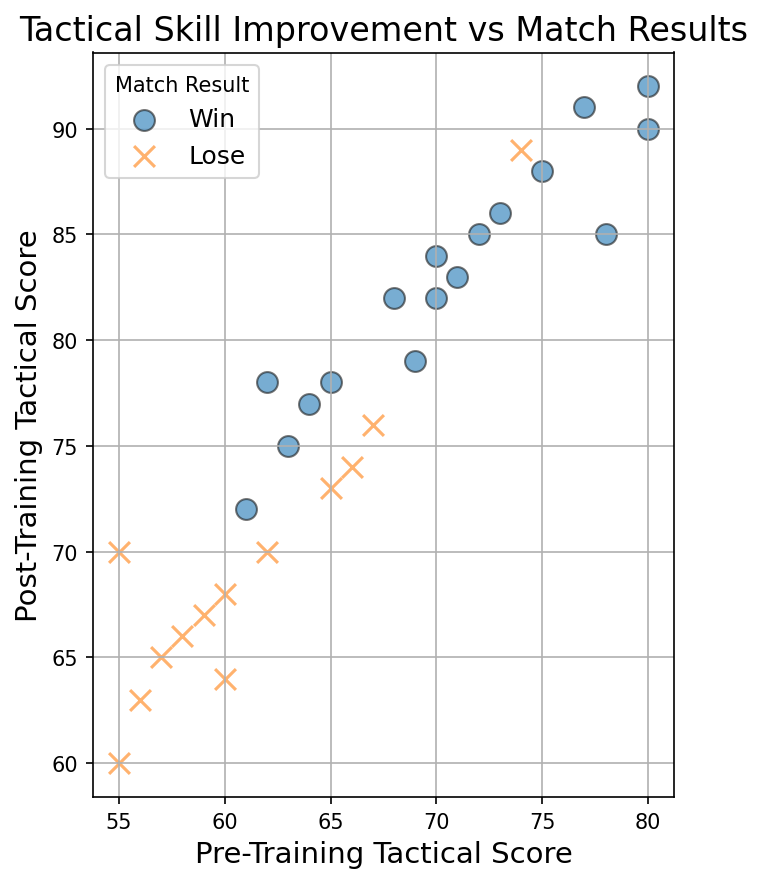What is the predominant result (Win or Lose) for players with high post-training tactical scores? By observing the color and shape of the marks, most of the high post-training tactical scores are blue circles, which corresponds to wins.
Answer: Win Which player had the lowest pre-training tactical score amongst those who won his matches? Identify the blue circles (wins) and find the pre-training tactical score with the lowest value. Player 27 had a pre-training score of 56.
Answer: Player 27 Is there any player with a higher pre-training tactical score but who lost the match after training compared to another player who won? Compare pre-training scores and match results. Player 21 had a pre-training score of 74 but lost, while Player 20 had a score of 73 and won.
Answer: Yes What's the range in post-training tactical scores for players who lost their matches? The range is calculated by finding the difference between the maximum and minimum post-training tactical scores of players who lost (orange X marks). The maximum is 89 and the minimum is 60. Therefore, the range is 89 - 60.
Answer: 29 Are there any players who had identical pre-training scores but different match results, and if so, what were their scores and results? Look for repeated pre-training scores with different colored markers. Player 60 appears twice, with one instance resulting in a win and another in a loss.
Answer: Yes, score 60 with both win and loss What is the average post-training tactical score for players who won their matches? Sum the post-training scores of all players who won and divide by the number of such players. (78 + 85 + 90 + 82 + 75 + 83 + 77 + 84 + 88 + 79 + 86 + 91 + 78 + 82 + 92 + 85) / 16 = 85.25
Answer: 85.25 Does a higher pre-training tactical score always result in a win after training? Compare high pre-training scores with both match results. Players with scores of 74 and above (players 4, 16, 20, and 28 won, while player 21 lost even though their scores were 80, 75, 73, 77, and 74 respectively). Player 21 had a pre-training score higher than some others but still lost.
Answer: No What's the difference in average post-training tactical scores between players who won and those who lost? Find the averages of post-training scores for both groups and calculate the difference. Winning average: 85.25. Losing average: (70 + 65 + 68 + 74 + 67 + 66 + 76 + 70 + 63 + 60 + 73 + 64) / 12 = 67.83. Difference: 85.25 - 67.83 = 17.42
Answer: 17.42 